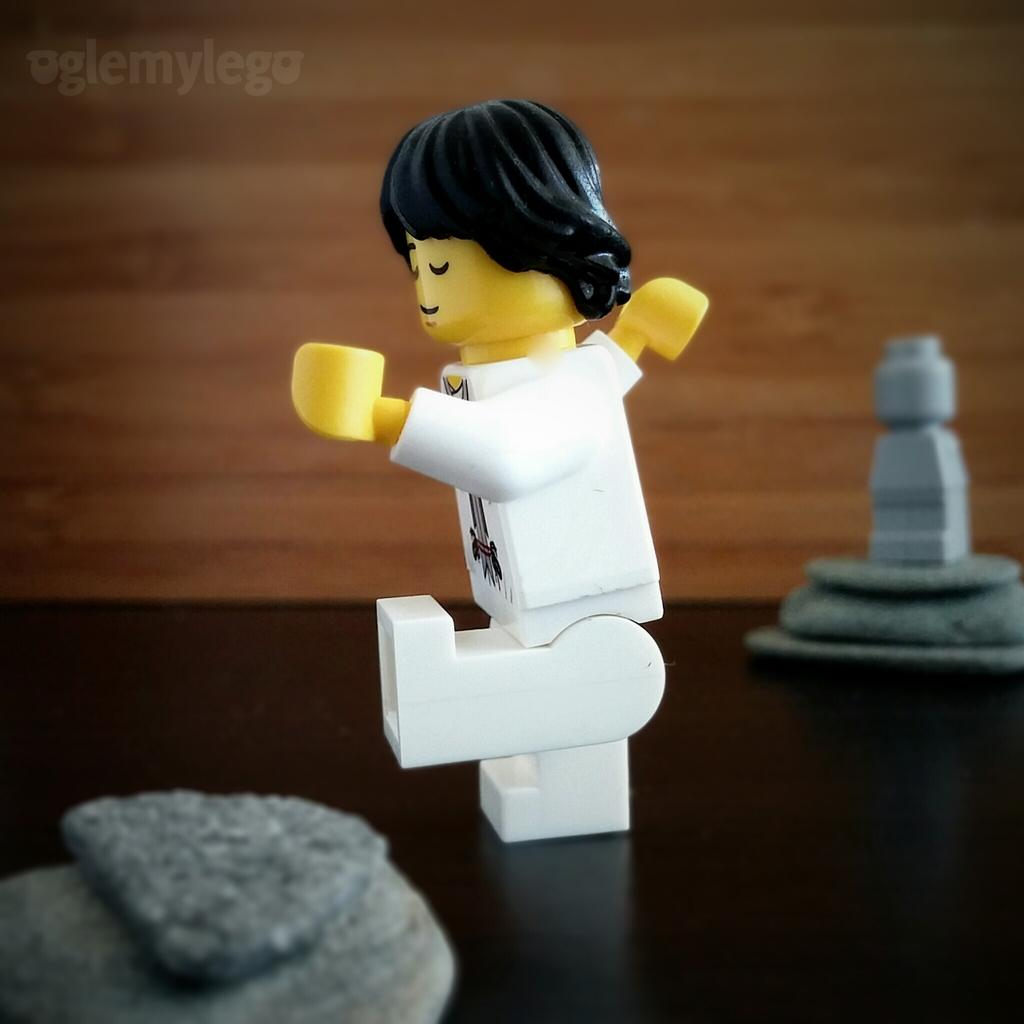What type of toy is present in the image? There is a human toy in the image. Where is the human toy located? The human toy is kept on a table. Are there any other toys visible in the image? Yes, there are other toys in the image. How does the human toy use its ear to listen to the sponge in the image? There is no sponge present in the image, and human toys do not have ears or the ability to listen. 